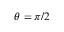Convert formula to latex. <formula><loc_0><loc_0><loc_500><loc_500>\theta = \pi / 2</formula> 